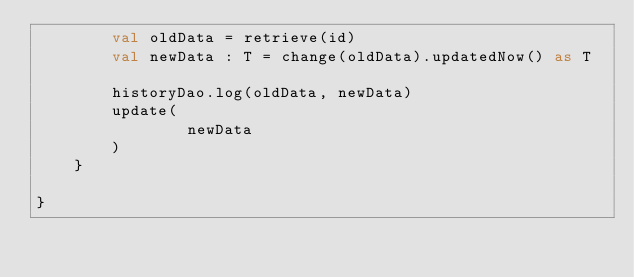<code> <loc_0><loc_0><loc_500><loc_500><_Kotlin_>		val oldData = retrieve(id)
		val newData : T = change(oldData).updatedNow() as T

		historyDao.log(oldData, newData)
		update(
				newData
		)
	}

}</code> 